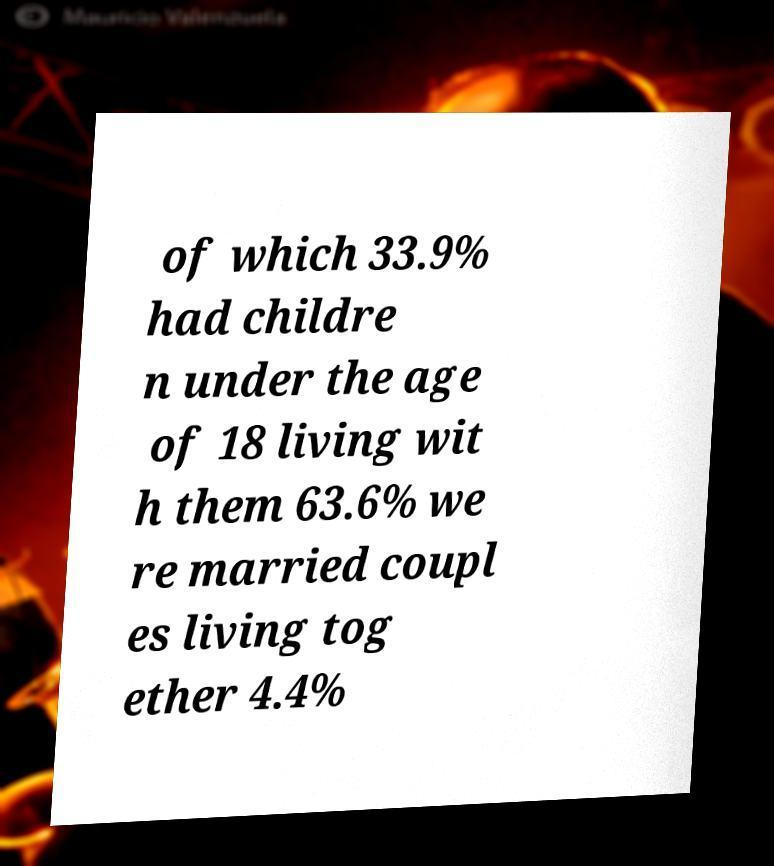Can you accurately transcribe the text from the provided image for me? of which 33.9% had childre n under the age of 18 living wit h them 63.6% we re married coupl es living tog ether 4.4% 